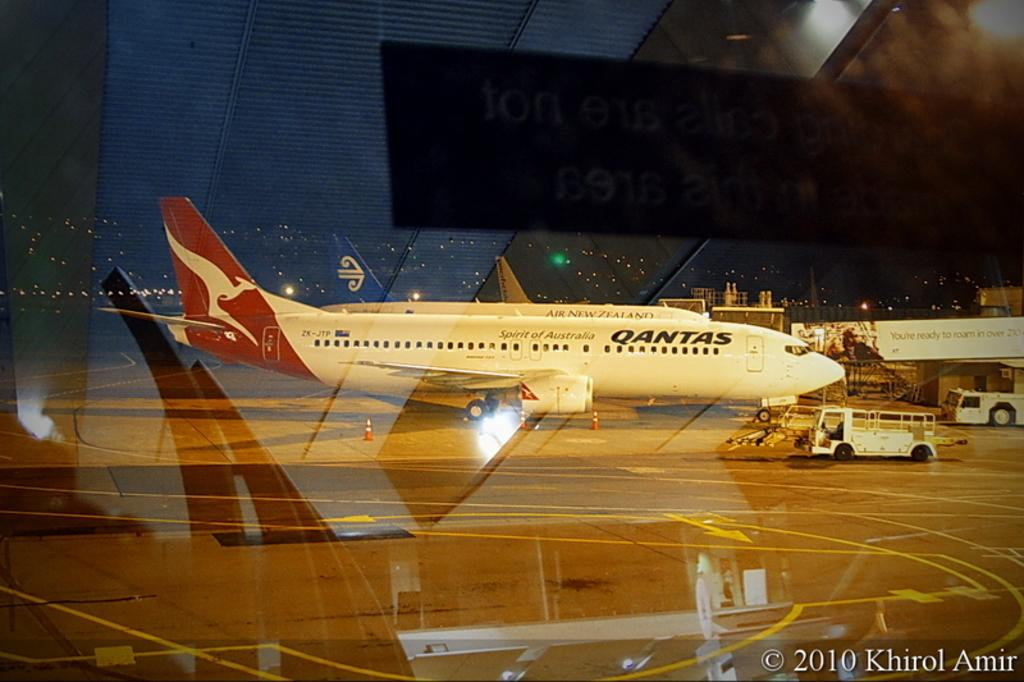<image>
Describe the image concisely. a Qantas plane at a gate looking from an inside window 